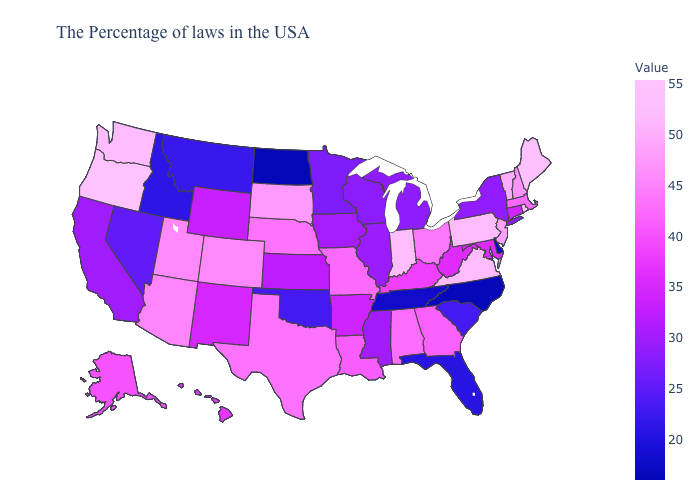Which states have the lowest value in the West?
Write a very short answer. Idaho. Which states have the lowest value in the USA?
Be succinct. North Dakota. Among the states that border West Virginia , which have the lowest value?
Short answer required. Maryland. Among the states that border Texas , which have the lowest value?
Write a very short answer. Oklahoma. Which states have the lowest value in the South?
Be succinct. North Carolina. Does the map have missing data?
Give a very brief answer. No. Does Arizona have the highest value in the USA?
Quick response, please. No. 